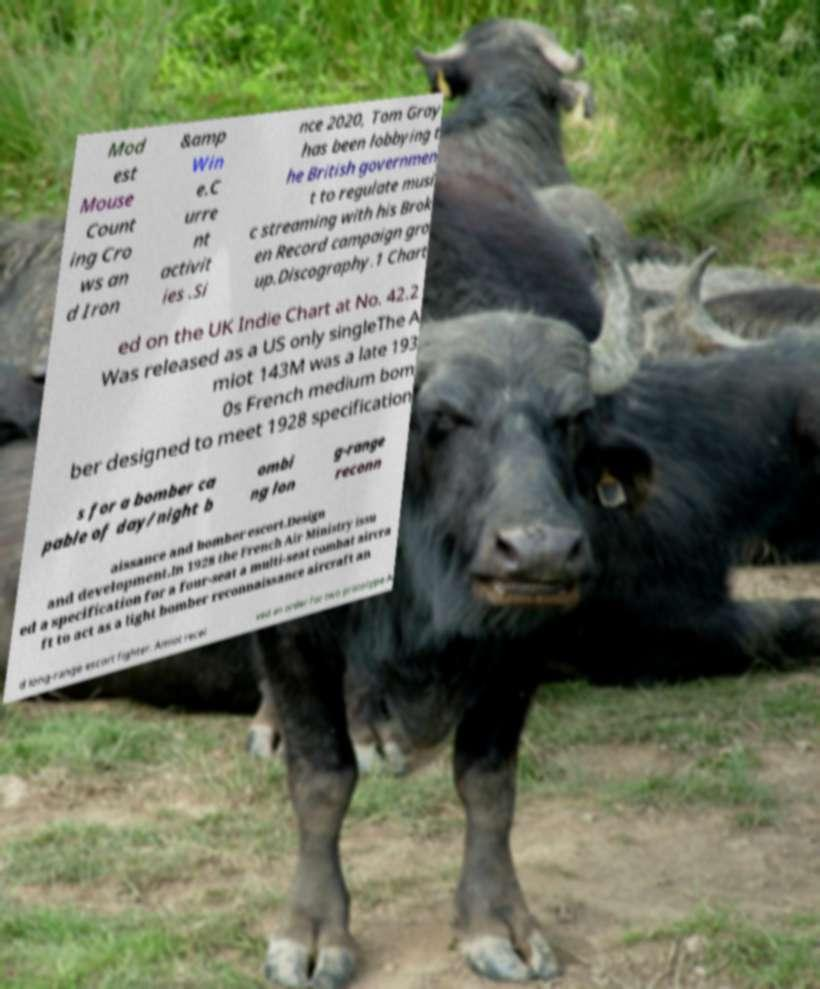There's text embedded in this image that I need extracted. Can you transcribe it verbatim? Mod est Mouse Count ing Cro ws an d Iron &amp Win e.C urre nt activit ies .Si nce 2020, Tom Gray has been lobbying t he British governmen t to regulate musi c streaming with his Brok en Record campaign gro up.Discography.1 Chart ed on the UK Indie Chart at No. 42.2 Was released as a US only singleThe A miot 143M was a late 193 0s French medium bom ber designed to meet 1928 specification s for a bomber ca pable of day/night b ombi ng lon g-range reconn aissance and bomber escort.Design and development.In 1928 the French Air Ministry issu ed a specification for a four-seat a multi-seat combat aircra ft to act as a light bomber reconnaissance aircraft an d long-range escort fighter. Amiot recei ved an order for two prototype A 